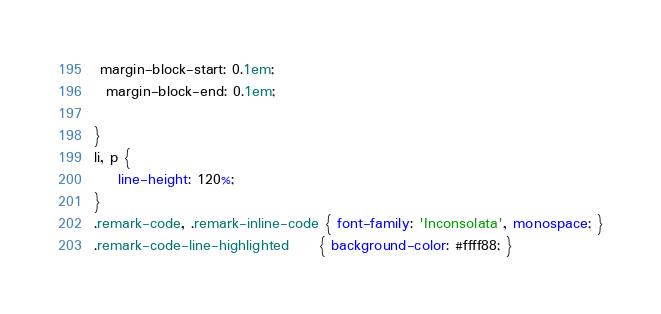Convert code to text. <code><loc_0><loc_0><loc_500><loc_500><_CSS_> margin-block-start: 0.1em;
  margin-block-end: 0.1em;

}
li, p {
    line-height: 120%;
}
.remark-code, .remark-inline-code { font-family: 'Inconsolata', monospace; }
.remark-code-line-highlighted     { background-color: #ffff88; }
</code> 